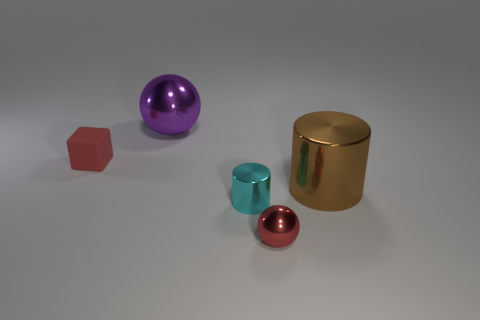Do the tiny ball and the big object that is in front of the big purple shiny ball have the same material?
Your answer should be very brief. Yes. What number of other things are the same shape as the large brown object?
Make the answer very short. 1. What number of objects are large objects in front of the big purple metal ball or rubber blocks to the left of the cyan shiny thing?
Give a very brief answer. 2. How many other objects are the same color as the cube?
Make the answer very short. 1. Is the number of tiny red matte objects that are on the right side of the tiny rubber object less than the number of small red rubber cubes that are right of the small red metallic sphere?
Ensure brevity in your answer.  No. How many gray objects are there?
Offer a very short reply. 0. Is there any other thing that is the same material as the small cyan thing?
Offer a very short reply. Yes. There is a tiny cyan thing that is the same shape as the brown shiny object; what is its material?
Ensure brevity in your answer.  Metal. Is the number of tiny cyan metal cylinders behind the block less than the number of tiny purple matte cubes?
Your answer should be compact. No. There is a small cyan metal object in front of the big brown metal cylinder; does it have the same shape as the red metal object?
Make the answer very short. No. 